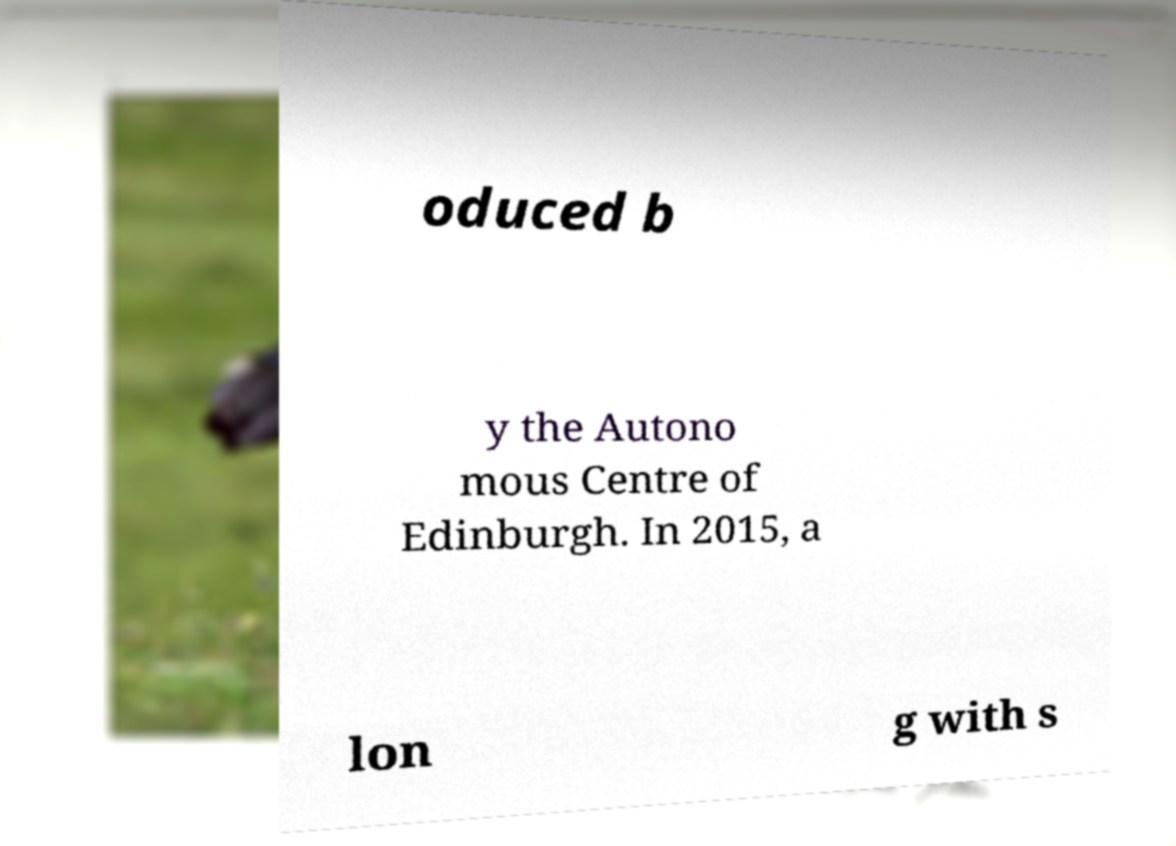Can you read and provide the text displayed in the image?This photo seems to have some interesting text. Can you extract and type it out for me? oduced b y the Autono mous Centre of Edinburgh. In 2015, a lon g with s 